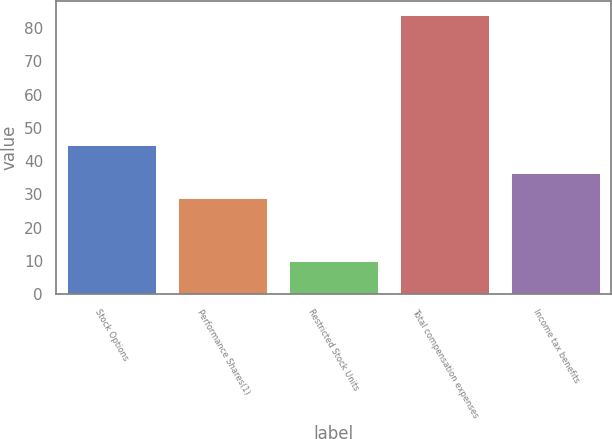Convert chart. <chart><loc_0><loc_0><loc_500><loc_500><bar_chart><fcel>Stock Options<fcel>Performance Shares(1)<fcel>Restricted Stock Units<fcel>Total compensation expenses<fcel>Income tax benefits<nl><fcel>45<fcel>29<fcel>10<fcel>84<fcel>36.4<nl></chart> 